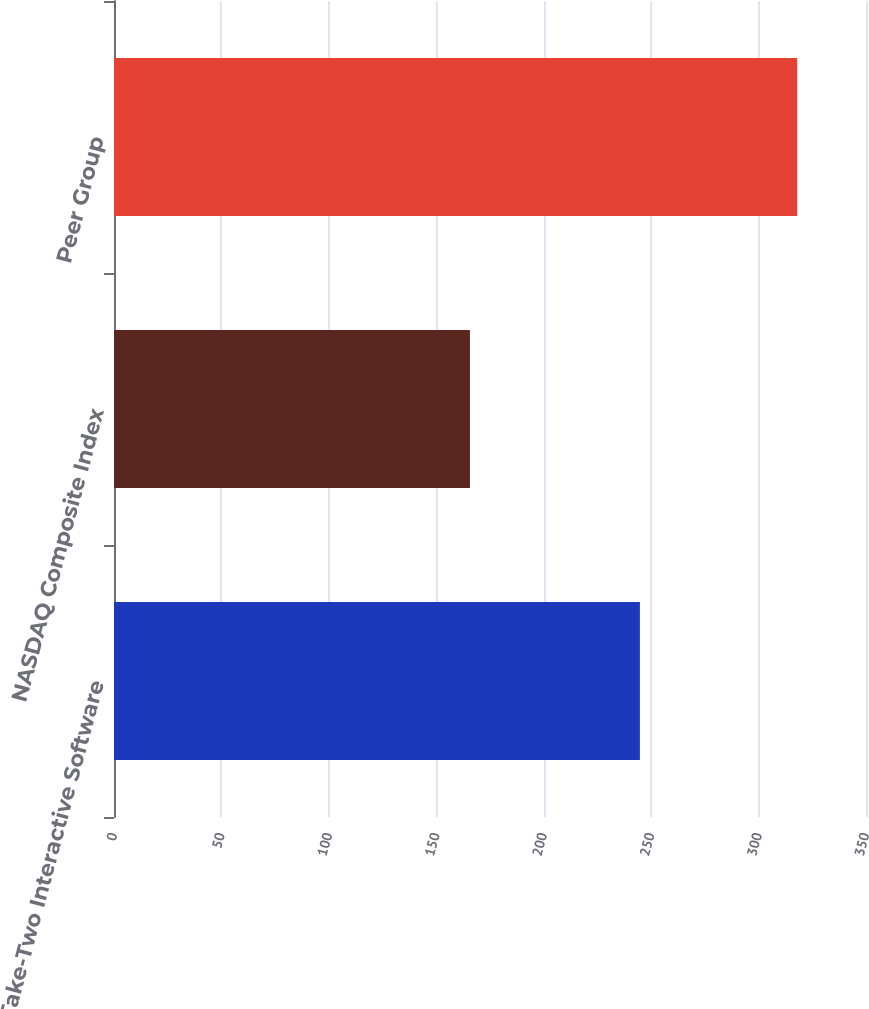<chart> <loc_0><loc_0><loc_500><loc_500><bar_chart><fcel>Take-Two Interactive Software<fcel>NASDAQ Composite Index<fcel>Peer Group<nl><fcel>244.77<fcel>165.66<fcel>318<nl></chart> 